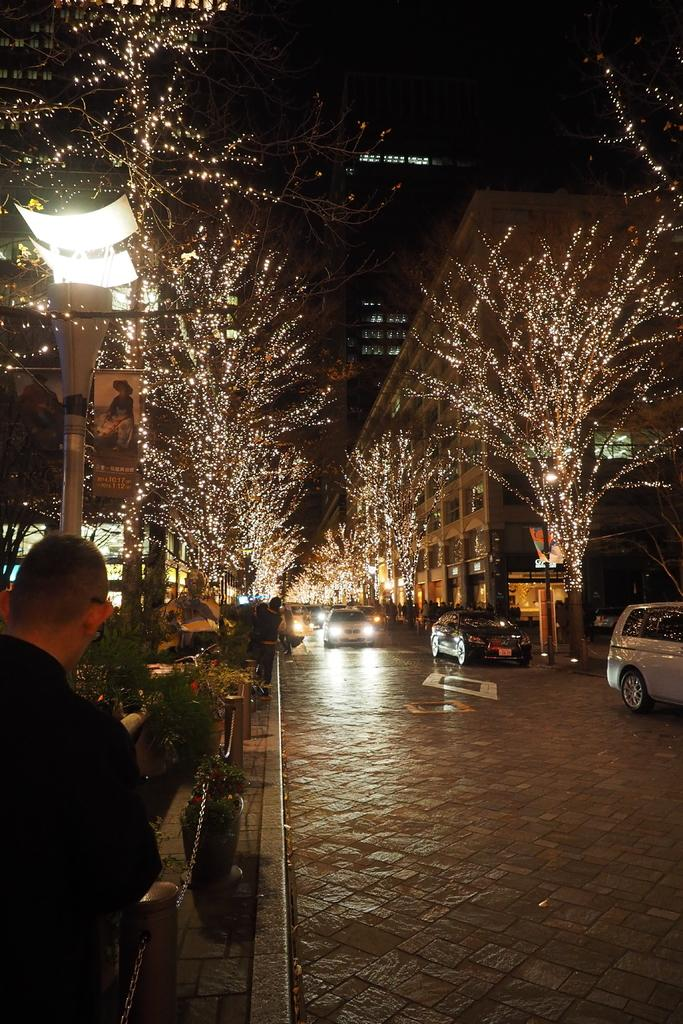What type of structures can be seen in the image? There are buildings in the image. What natural elements are present in the image? There are many trees in the image. What mode of transportation can be observed in the image? Cars are moving on the road in the image. Can you describe the person in the image? A man is standing at the left bottom of the image. What type of wool is being spun by the man in the image? There is no man spinning wool in the image; the man is simply standing at the left bottom of the image. 